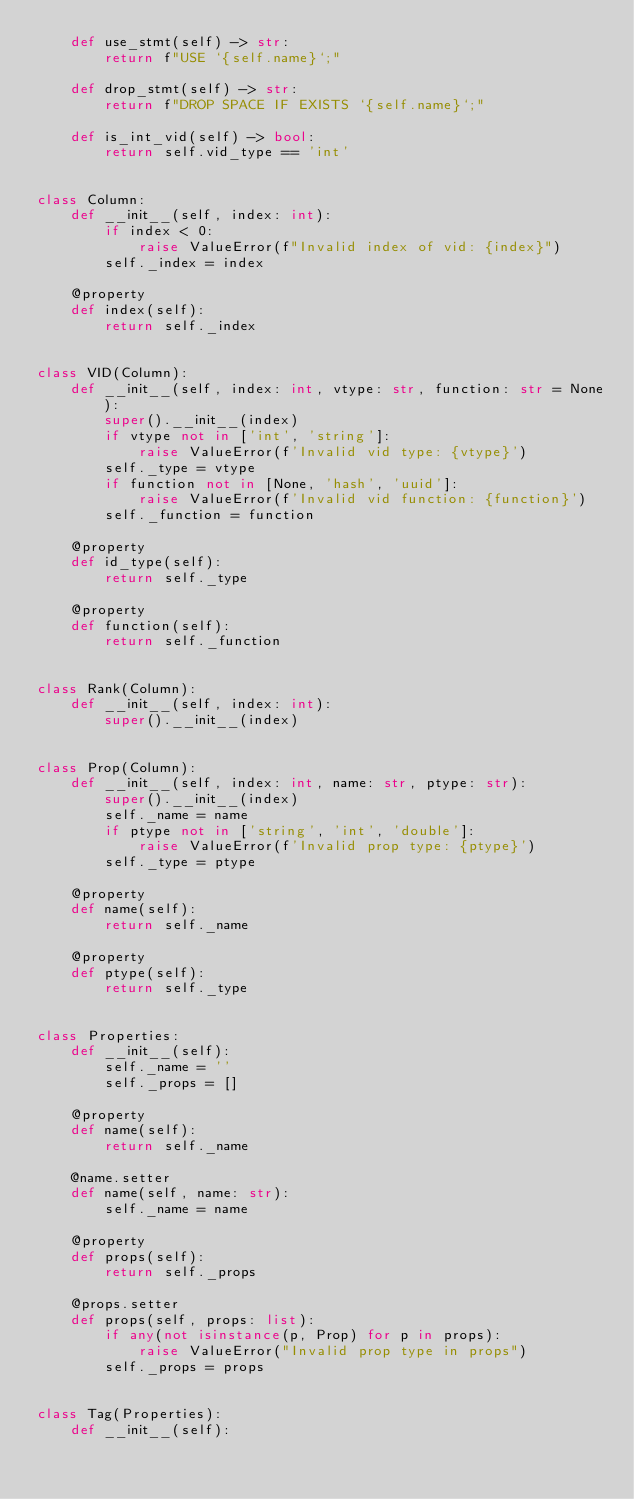Convert code to text. <code><loc_0><loc_0><loc_500><loc_500><_Python_>    def use_stmt(self) -> str:
        return f"USE `{self.name}`;"

    def drop_stmt(self) -> str:
        return f"DROP SPACE IF EXISTS `{self.name}`;"

    def is_int_vid(self) -> bool:
        return self.vid_type == 'int'


class Column:
    def __init__(self, index: int):
        if index < 0:
            raise ValueError(f"Invalid index of vid: {index}")
        self._index = index

    @property
    def index(self):
        return self._index


class VID(Column):
    def __init__(self, index: int, vtype: str, function: str = None):
        super().__init__(index)
        if vtype not in ['int', 'string']:
            raise ValueError(f'Invalid vid type: {vtype}')
        self._type = vtype
        if function not in [None, 'hash', 'uuid']:
            raise ValueError(f'Invalid vid function: {function}')
        self._function = function

    @property
    def id_type(self):
        return self._type

    @property
    def function(self):
        return self._function


class Rank(Column):
    def __init__(self, index: int):
        super().__init__(index)


class Prop(Column):
    def __init__(self, index: int, name: str, ptype: str):
        super().__init__(index)
        self._name = name
        if ptype not in ['string', 'int', 'double']:
            raise ValueError(f'Invalid prop type: {ptype}')
        self._type = ptype

    @property
    def name(self):
        return self._name

    @property
    def ptype(self):
        return self._type


class Properties:
    def __init__(self):
        self._name = ''
        self._props = []

    @property
    def name(self):
        return self._name

    @name.setter
    def name(self, name: str):
        self._name = name

    @property
    def props(self):
        return self._props

    @props.setter
    def props(self, props: list):
        if any(not isinstance(p, Prop) for p in props):
            raise ValueError("Invalid prop type in props")
        self._props = props


class Tag(Properties):
    def __init__(self):</code> 